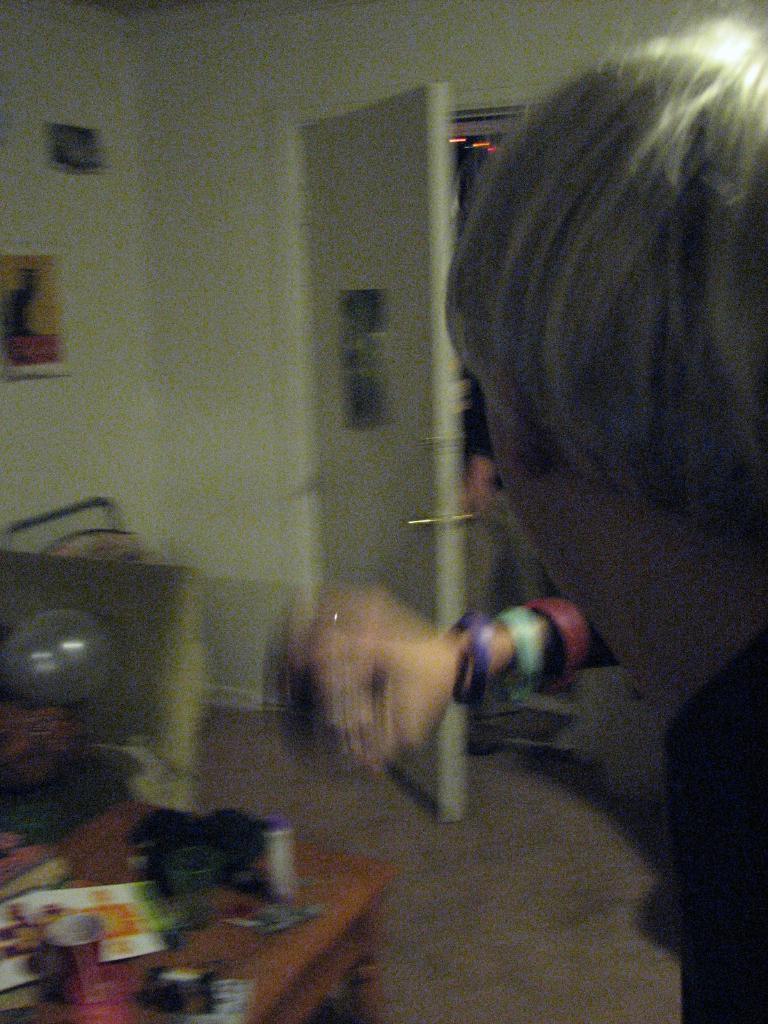Could you give a brief overview of what you see in this image? In the image we can see there is a person and there is glass, bottle and paper and kept on the table. There is a sofa and there is a photo frame on the wall. Behind there is a door and background of the image is little blurred. 